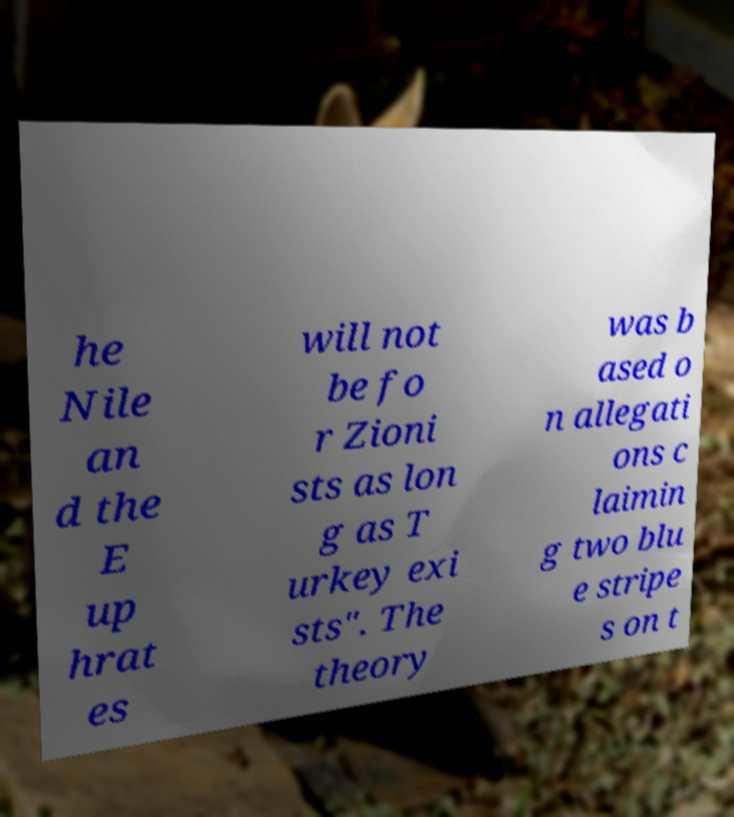For documentation purposes, I need the text within this image transcribed. Could you provide that? he Nile an d the E up hrat es will not be fo r Zioni sts as lon g as T urkey exi sts". The theory was b ased o n allegati ons c laimin g two blu e stripe s on t 